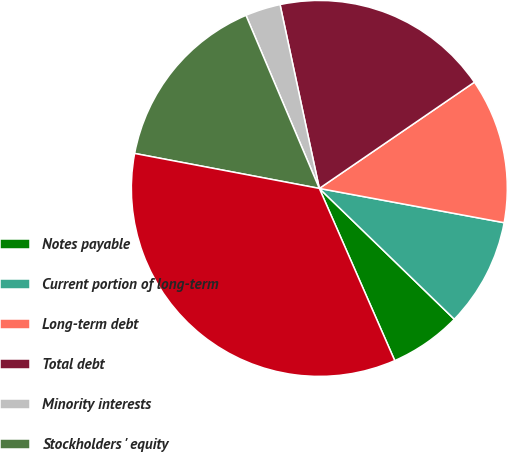Convert chart to OTSL. <chart><loc_0><loc_0><loc_500><loc_500><pie_chart><fcel>Notes payable<fcel>Current portion of long-term<fcel>Long-term debt<fcel>Total debt<fcel>Minority interests<fcel>Stockholders ' equity<fcel>Total Capital<nl><fcel>6.18%<fcel>9.33%<fcel>12.48%<fcel>18.79%<fcel>3.03%<fcel>15.64%<fcel>34.55%<nl></chart> 